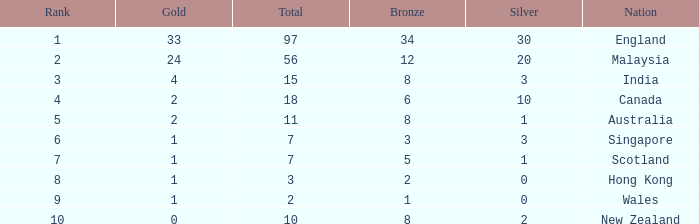What is the total number of bronze a team with more than 0 silver, a total of 7 medals, and less than 1 gold medal has? 0.0. 